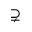<formula> <loc_0><loc_0><loc_500><loc_500>\supsetneq</formula> 